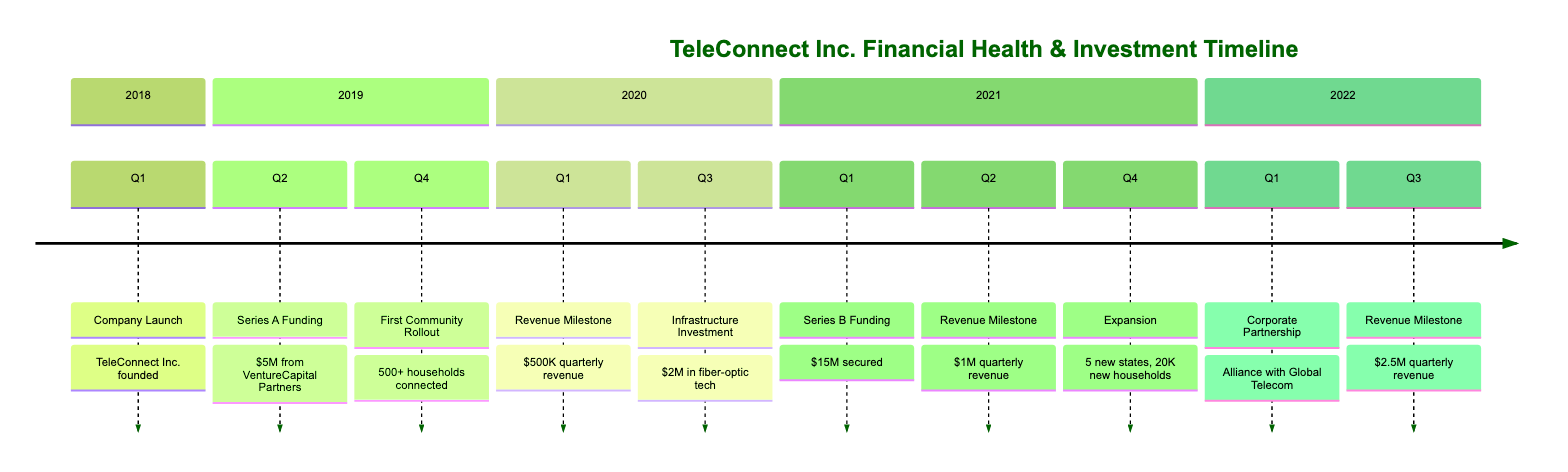What year was TeleConnect Inc. founded? The diagram lists the event "Company Launch" in Q1 2018, which indicates the year TeleConnect Inc. was founded.
Answer: 2018 How much was secured in Series A funding? According to the Q2 2019 event labeled "Series A Funding," it states that $5 million was secured from VentureCapital Partners.
Answer: $5 million What was the quarterly revenue in Q1 2020? The diagram specifies the event "Quarterly Revenue Milestone" in Q1 2020, indicating that the company reached $500,000 in quarterly revenue at that time.
Answer: $500,000 How many households were connected during the first community rollout? The diagram states that in Q4 2019, during the "First Community Rollout," over 500 households were provided internet access.
Answer: 500+ What investment was made in Q3 2020? The diagram includes the event "Infrastructure Investment" in Q3 2020, which mentions a $2 million investment in upgrading network infrastructure with fiber-optic technology.
Answer: $2 million Which funding round allowed for expansion to underserved areas in 2021? The diagram indicates that the Series B Funding in Q1 2021 secured $15 million, which enabled further expansion to underserved areas.
Answer: Series B Funding What was the quarterly revenue milestone reached in Q3 2022? The event listed in Q3 2022 shows that the company reported a quarterly revenue of $2.5 million, which is the milestone reached at that time.
Answer: $2.5 million How many new states did the company expand to in Q4 2021? The "Expansion to New States" event in Q4 2021 details that the company expanded services to five additional states.
Answer: 5 What major partnership was formed in Q1 2022? The timeline indicates a "Major Corporate Partnership" in Q1 2022, specifying that TeleConnect Inc. formed an alliance with Global Telecom.
Answer: Global Telecom How many new households were added during the expansion in Q4 2021? The diagram shows that in Q4 2021, the company increased its customer base by 20,000 households during the expansion.
Answer: 20,000 